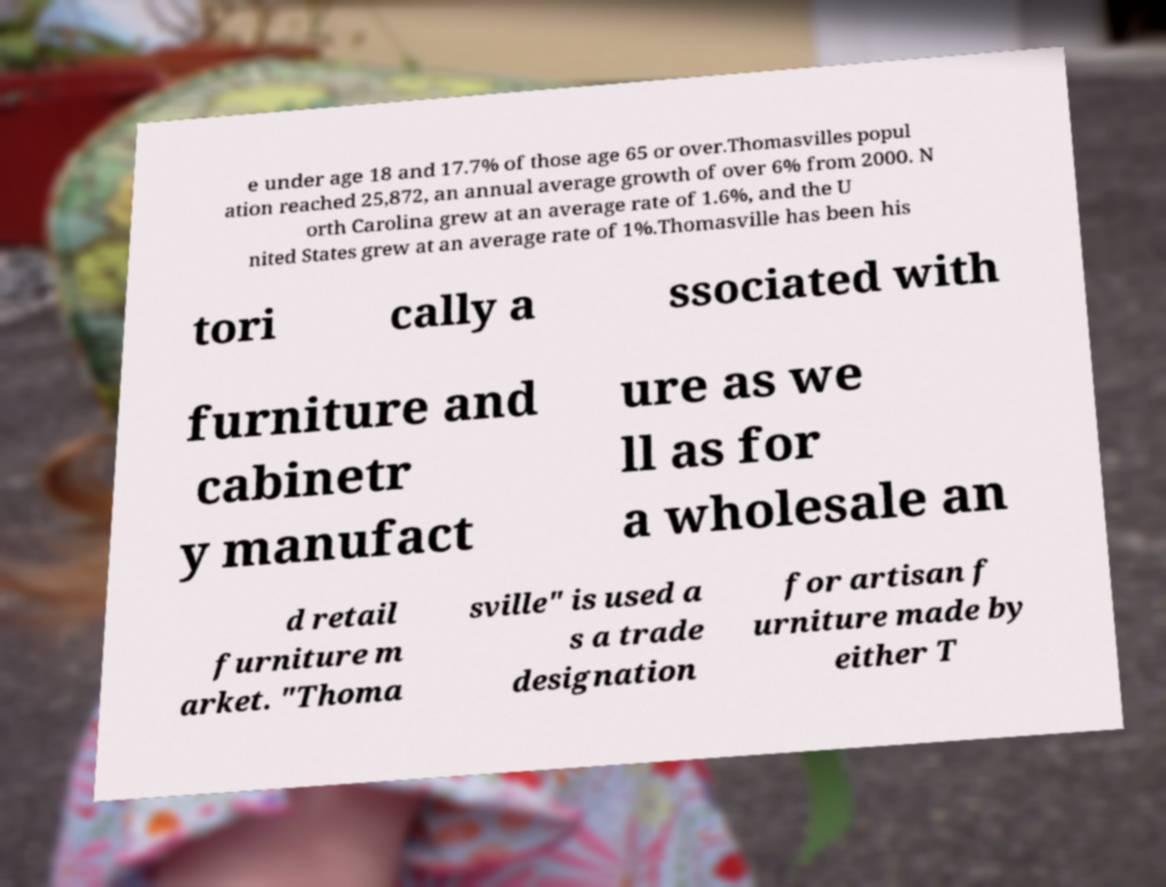I need the written content from this picture converted into text. Can you do that? e under age 18 and 17.7% of those age 65 or over.Thomasvilles popul ation reached 25,872, an annual average growth of over 6% from 2000. N orth Carolina grew at an average rate of 1.6%, and the U nited States grew at an average rate of 1%.Thomasville has been his tori cally a ssociated with furniture and cabinetr y manufact ure as we ll as for a wholesale an d retail furniture m arket. "Thoma sville" is used a s a trade designation for artisan f urniture made by either T 